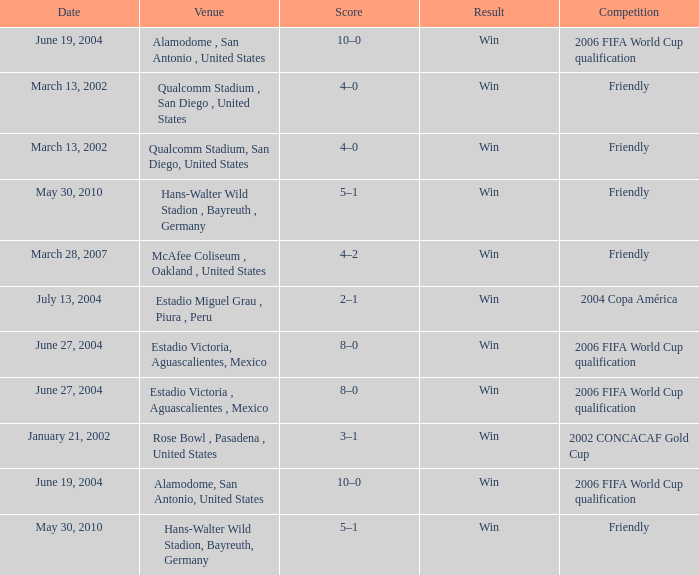What is the date of the 2006 fifa world cup qualification event that took place at the alamodome in san antonio, united states? June 19, 2004, June 19, 2004. 